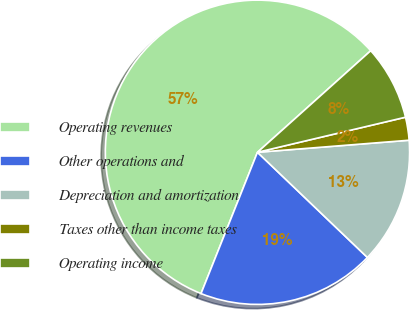<chart> <loc_0><loc_0><loc_500><loc_500><pie_chart><fcel>Operating revenues<fcel>Other operations and<fcel>Depreciation and amortization<fcel>Taxes other than income taxes<fcel>Operating income<nl><fcel>57.32%<fcel>18.9%<fcel>13.41%<fcel>2.44%<fcel>7.93%<nl></chart> 